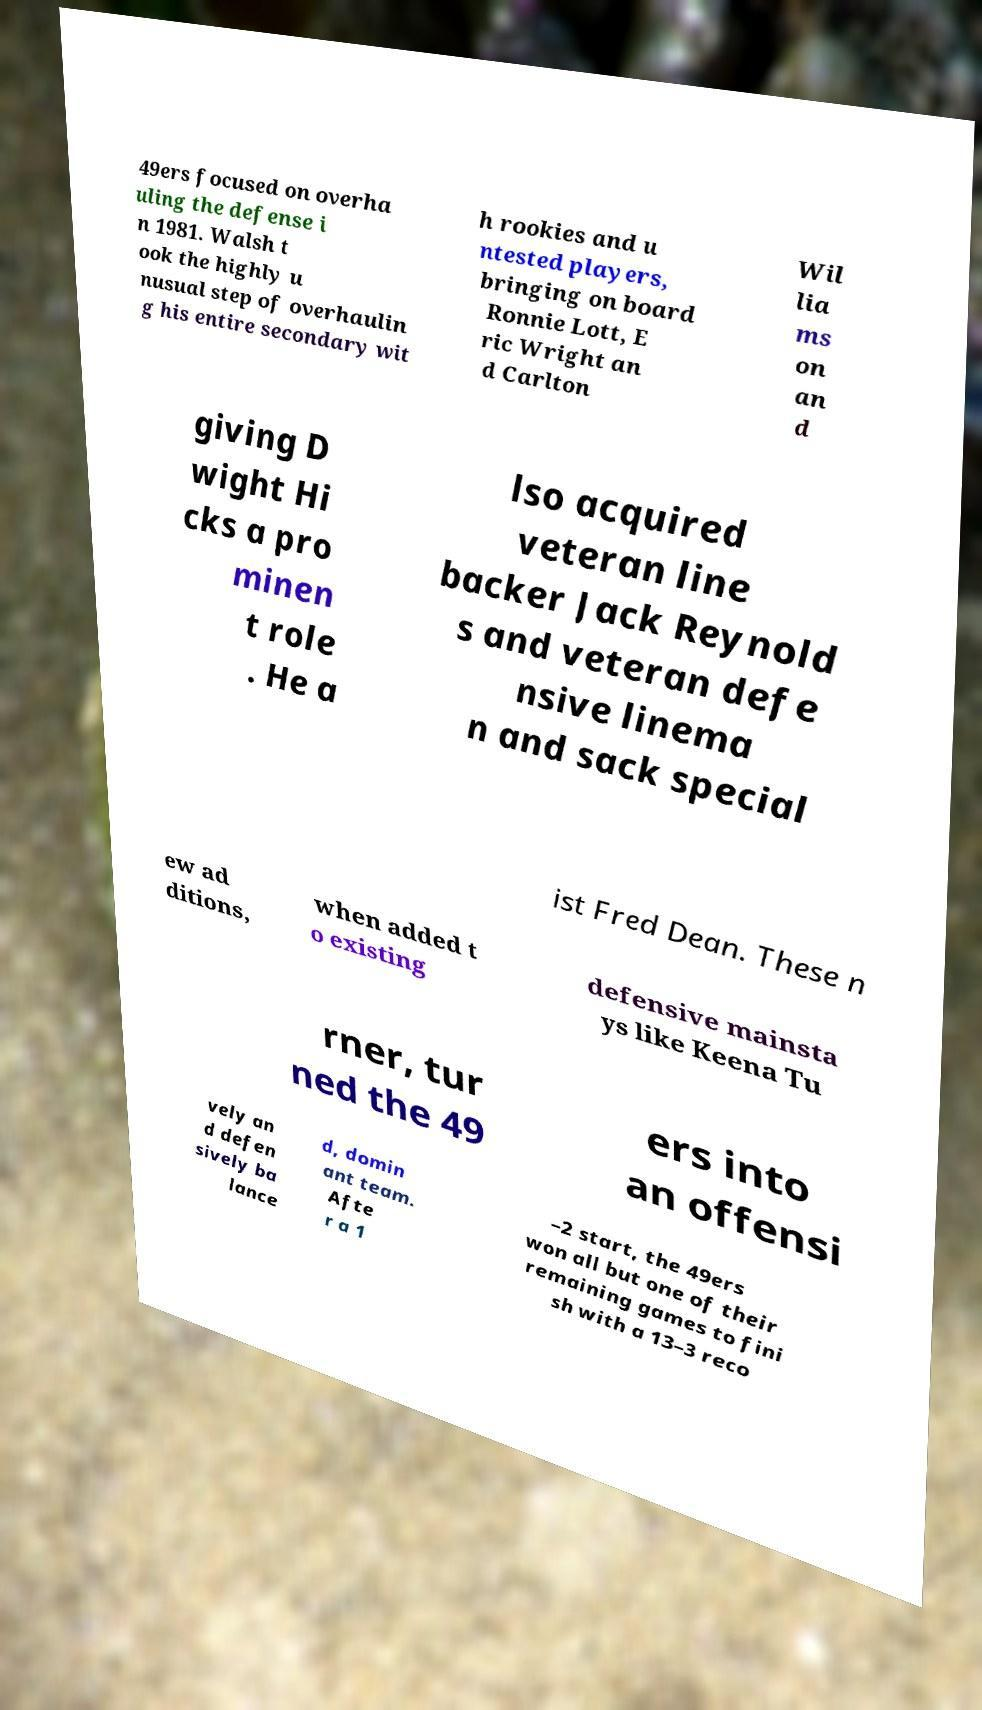Could you assist in decoding the text presented in this image and type it out clearly? 49ers focused on overha uling the defense i n 1981. Walsh t ook the highly u nusual step of overhaulin g his entire secondary wit h rookies and u ntested players, bringing on board Ronnie Lott, E ric Wright an d Carlton Wil lia ms on an d giving D wight Hi cks a pro minen t role . He a lso acquired veteran line backer Jack Reynold s and veteran defe nsive linema n and sack special ist Fred Dean. These n ew ad ditions, when added t o existing defensive mainsta ys like Keena Tu rner, tur ned the 49 ers into an offensi vely an d defen sively ba lance d, domin ant team. Afte r a 1 –2 start, the 49ers won all but one of their remaining games to fini sh with a 13–3 reco 